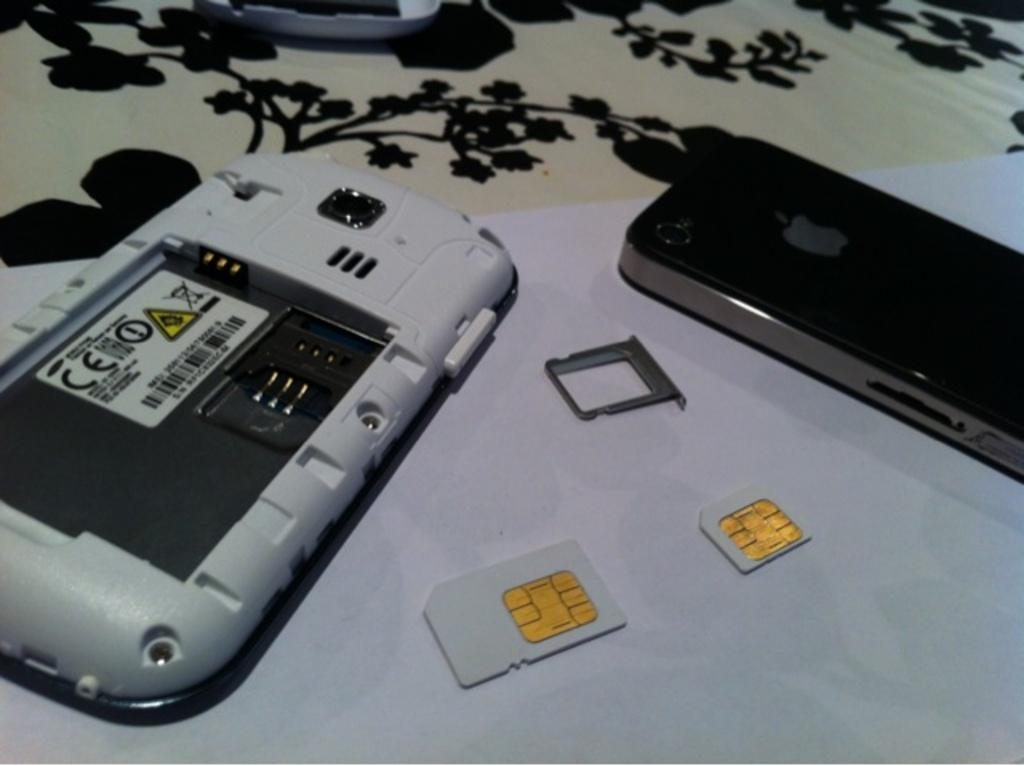What type of objects can be seen in the image? There are mobiles, sim cards, and houseplants in the image. Can you describe the electronic devices in the image? The mobiles and sim cards are electronic devices in the image. What type of vegetation is present in the image? There are houseplants in the image. What might be the time of day when the image was taken? The image may have been taken during the night, as there is no indication of daylight. How many oranges are being ploughed in the image? There are no oranges or ploughs present in the image. What type of twist can be seen in the image? There is no twist visible in the image. 